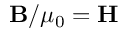<formula> <loc_0><loc_0><loc_500><loc_500>B / \mu _ { 0 } = H</formula> 